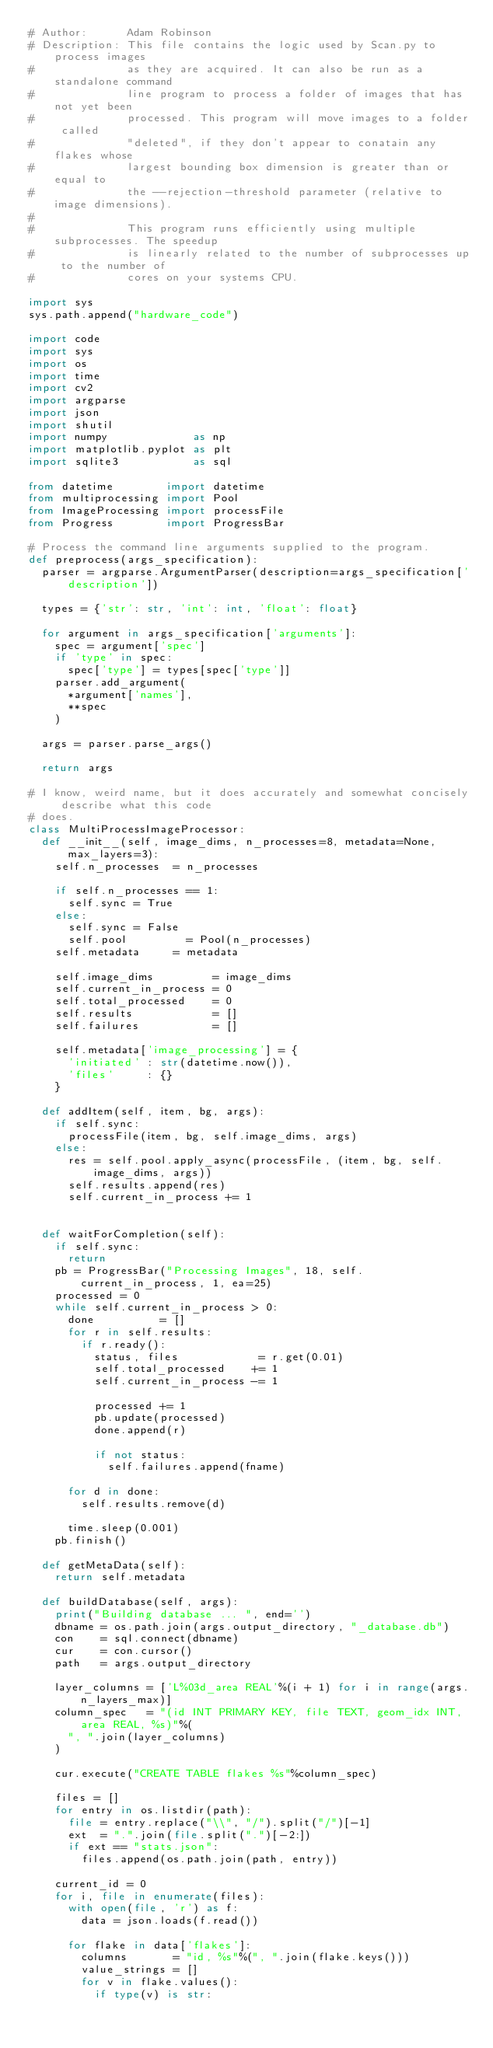Convert code to text. <code><loc_0><loc_0><loc_500><loc_500><_Python_># Author:      Adam Robinson
# Description: This file contains the logic used by Scan.py to process images
#              as they are acquired. It can also be run as a standalone command
#              line program to process a folder of images that has not yet been
#              processed. This program will move images to a folder called 
#              "deleted", if they don't appear to conatain any flakes whose 
#              largest bounding box dimension is greater than or equal to 
#              the --rejection-threshold parameter (relative to image dimensions).
#
#              This program runs efficiently using multiple subprocesses. The speedup
#              is linearly related to the number of subprocesses up to the number of
#              cores on your systems CPU. 

import sys
sys.path.append("hardware_code")

import code
import sys
import os
import time
import cv2
import argparse
import json
import shutil
import numpy             as np
import matplotlib.pyplot as plt
import sqlite3           as sql

from datetime        import datetime
from multiprocessing import Pool
from ImageProcessing import processFile
from Progress        import ProgressBar

# Process the command line arguments supplied to the program.
def preprocess(args_specification):
	parser = argparse.ArgumentParser(description=args_specification['description'])

	types = {'str': str, 'int': int, 'float': float}

	for argument in args_specification['arguments']:
		spec = argument['spec']
		if 'type' in spec:
			spec['type'] = types[spec['type']]
		parser.add_argument(
			*argument['names'], 
			**spec
		)

	args = parser.parse_args()

	return args

# I know, weird name, but it does accurately and somewhat concisely describe what this code
# does.
class MultiProcessImageProcessor:
	def __init__(self, image_dims, n_processes=8, metadata=None, max_layers=3):
		self.n_processes  = n_processes

		if self.n_processes == 1:
			self.sync = True
		else:
			self.sync = False
			self.pool         = Pool(n_processes)
		self.metadata     = metadata

		self.image_dims         = image_dims
		self.current_in_process = 0
		self.total_processed    = 0
		self.results            = []
		self.failures           = []

		self.metadata['image_processing'] = {
			'initiated' : str(datetime.now()),
			'files'     : {}
		}

	def addItem(self, item, bg, args):
		if self.sync:
			processFile(item, bg, self.image_dims, args)
		else:
			res = self.pool.apply_async(processFile, (item, bg, self.image_dims, args))
			self.results.append(res)
			self.current_in_process += 1


	def waitForCompletion(self):
		if self.sync:
			return
		pb = ProgressBar("Processing Images", 18, self.current_in_process, 1, ea=25)
		processed = 0
		while self.current_in_process > 0:
			done          = []
			for r in self.results:
				if r.ready():
					status, files            = r.get(0.01)
					self.total_processed    += 1
					self.current_in_process -= 1
					
					processed += 1
					pb.update(processed)
					done.append(r)

					if not status:
						self.failures.append(fname)

			for d in done:
				self.results.remove(d)

			time.sleep(0.001)
		pb.finish()

	def getMetaData(self):
		return self.metadata

	def buildDatabase(self, args):
		print("Building database ... ", end='')
		dbname = os.path.join(args.output_directory, "_database.db")
		con    = sql.connect(dbname)
		cur    = con.cursor()
		path   = args.output_directory

		layer_columns = ['L%03d_area REAL'%(i + 1) for i in range(args.n_layers_max)]
		column_spec   = "(id INT PRIMARY KEY, file TEXT, geom_idx INT, area REAL, %s)"%(
			", ".join(layer_columns)
		)

		cur.execute("CREATE TABLE flakes %s"%column_spec)

		files = []
		for entry in os.listdir(path):
			file = entry.replace("\\", "/").split("/")[-1]
			ext  = ".".join(file.split(".")[-2:])
			if ext == "stats.json":
				files.append(os.path.join(path, entry))

		current_id = 0
		for i, file in enumerate(files):
			with open(file, 'r') as f:
				data = json.loads(f.read())

			for flake in data['flakes']:
				columns       = "id, %s"%(", ".join(flake.keys()))
				value_strings = []
				for v in flake.values():
					if type(v) is str:</code> 